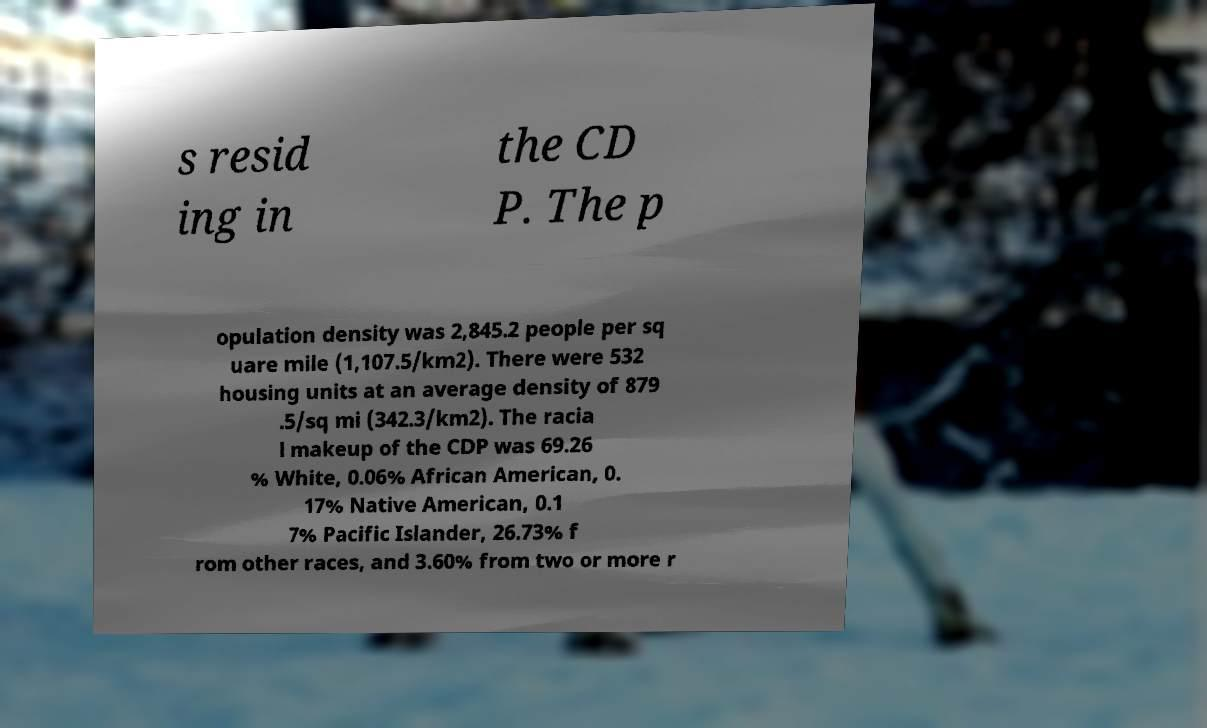Please read and relay the text visible in this image. What does it say? s resid ing in the CD P. The p opulation density was 2,845.2 people per sq uare mile (1,107.5/km2). There were 532 housing units at an average density of 879 .5/sq mi (342.3/km2). The racia l makeup of the CDP was 69.26 % White, 0.06% African American, 0. 17% Native American, 0.1 7% Pacific Islander, 26.73% f rom other races, and 3.60% from two or more r 